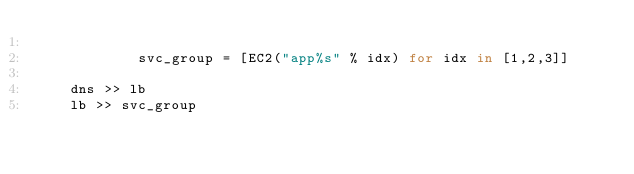<code> <loc_0><loc_0><loc_500><loc_500><_Python_>
            svc_group = [EC2("app%s" % idx) for idx in [1,2,3]]

    dns >> lb
    lb >> svc_group
</code> 